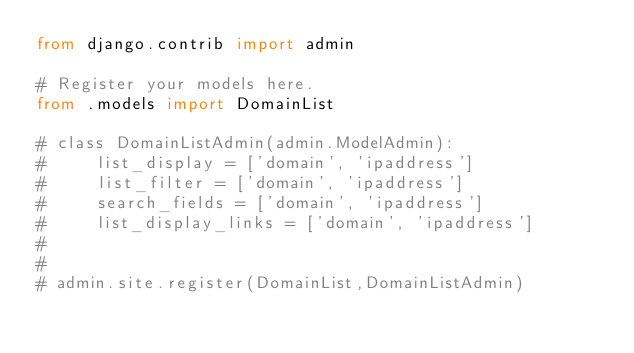<code> <loc_0><loc_0><loc_500><loc_500><_Python_>from django.contrib import admin

# Register your models here.
from .models import DomainList

# class DomainListAdmin(admin.ModelAdmin):
#     list_display = ['domain', 'ipaddress']
#     list_filter = ['domain', 'ipaddress']
#     search_fields = ['domain', 'ipaddress']
#     list_display_links = ['domain', 'ipaddress']
#
#
# admin.site.register(DomainList,DomainListAdmin)
</code> 